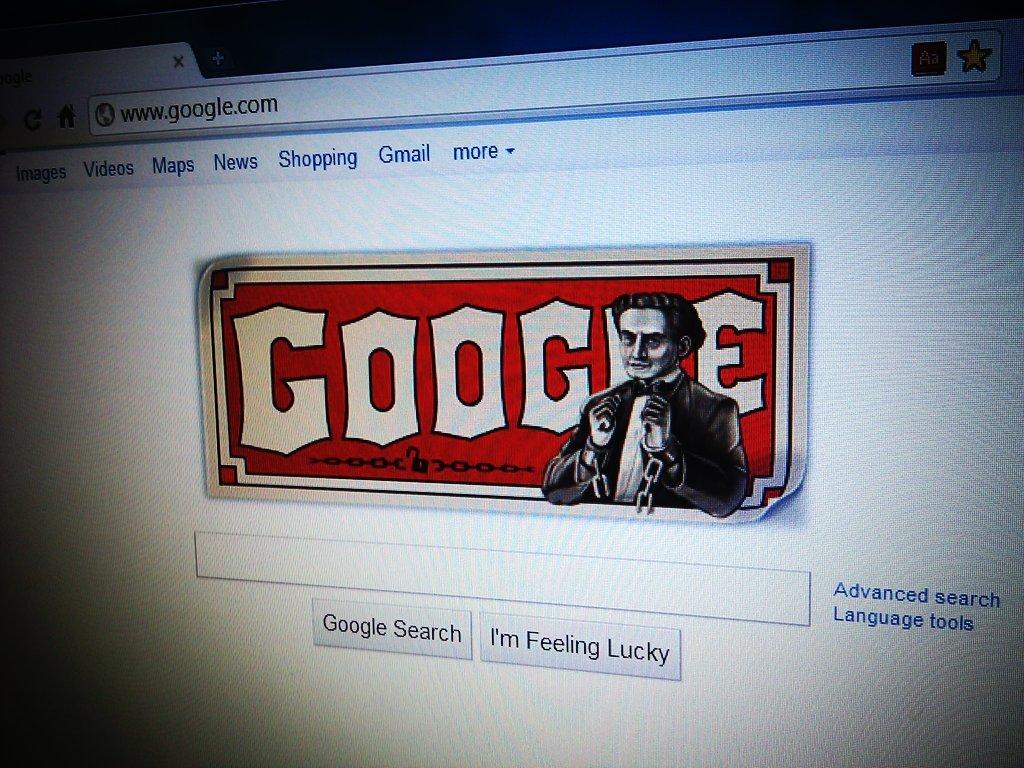Who is feeling lucky?
Keep it short and to the point. I'm. 